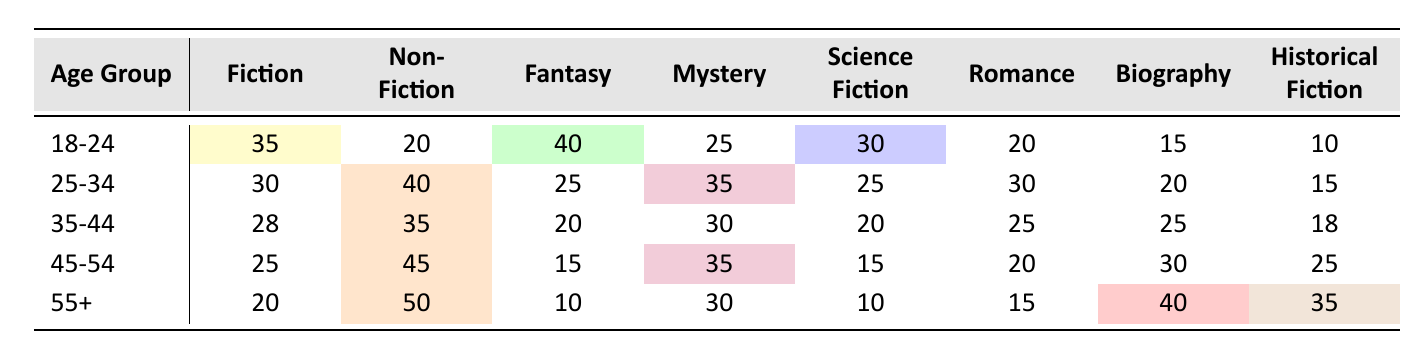What is the most preferred genre for the 18-24 age group? In the 18-24 age group, the highest value in the table is for Fantasy, which has a value of 40.
Answer: Fantasy Which age group has the highest preference for Non-Fiction? The age group 55+ has the highest preference for Non-Fiction with a value of 50.
Answer: 55+ What is the average preference for Romance across all age groups? To find the average, add the values: (20 + 30 + 25 + 20 + 15) = 110 and divide by 5 (number of age groups). The average is 110/5 = 22.
Answer: 22 Is Fiction more preferred than Mystery for the 25-34 age group? For the 25-34 age group, Fiction has a value of 30 while Mystery has a value of 35. Hence, Fiction is not preferred more than Mystery.
Answer: No Which genre has the lowest preference among the 45-54 age group? Among the 45-54 age group, Fantasy has the lowest preference with a value of 15.
Answer: Fantasy What is the total preference for Biography across all age groups? To find the total for Biography, add the respective values: (15 + 20 + 25 + 30 + 40) = 130.
Answer: 130 Which age group prefers Science Fiction the least? The age group 55+ has the least preference for Science Fiction with a value of 10, which is lower than all other age groups.
Answer: 55+ What is the difference in preference for Historical Fiction between age groups 35-44 and 45-54? The values for Historical Fiction are 18 for age group 35-44 and 25 for age group 45-54. The difference is 25 - 18 = 7.
Answer: 7 